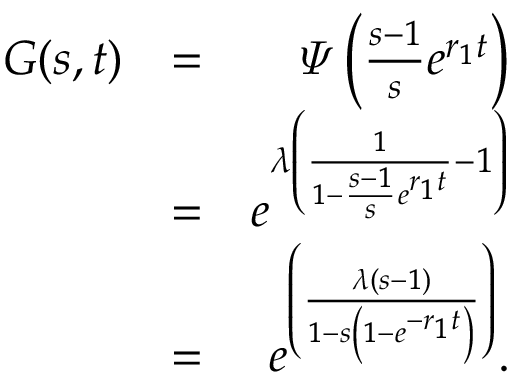<formula> <loc_0><loc_0><loc_500><loc_500>\begin{array} { r l r } { G ( s , t ) } & { = } & { \varPsi \left ( \frac { s - 1 } { s } e ^ { r _ { 1 } t } \right ) } \\ & { = } & { e ^ { \lambda \left ( \frac { 1 } { 1 - \frac { s - 1 } { s } e ^ { r _ { 1 } t } } - 1 \right ) } } \\ & { = } & { e ^ { \left ( \frac { \lambda ( s - 1 ) } { 1 - s \left ( 1 - e ^ { - r _ { 1 } t } \right ) } \right ) } . } \end{array}</formula> 